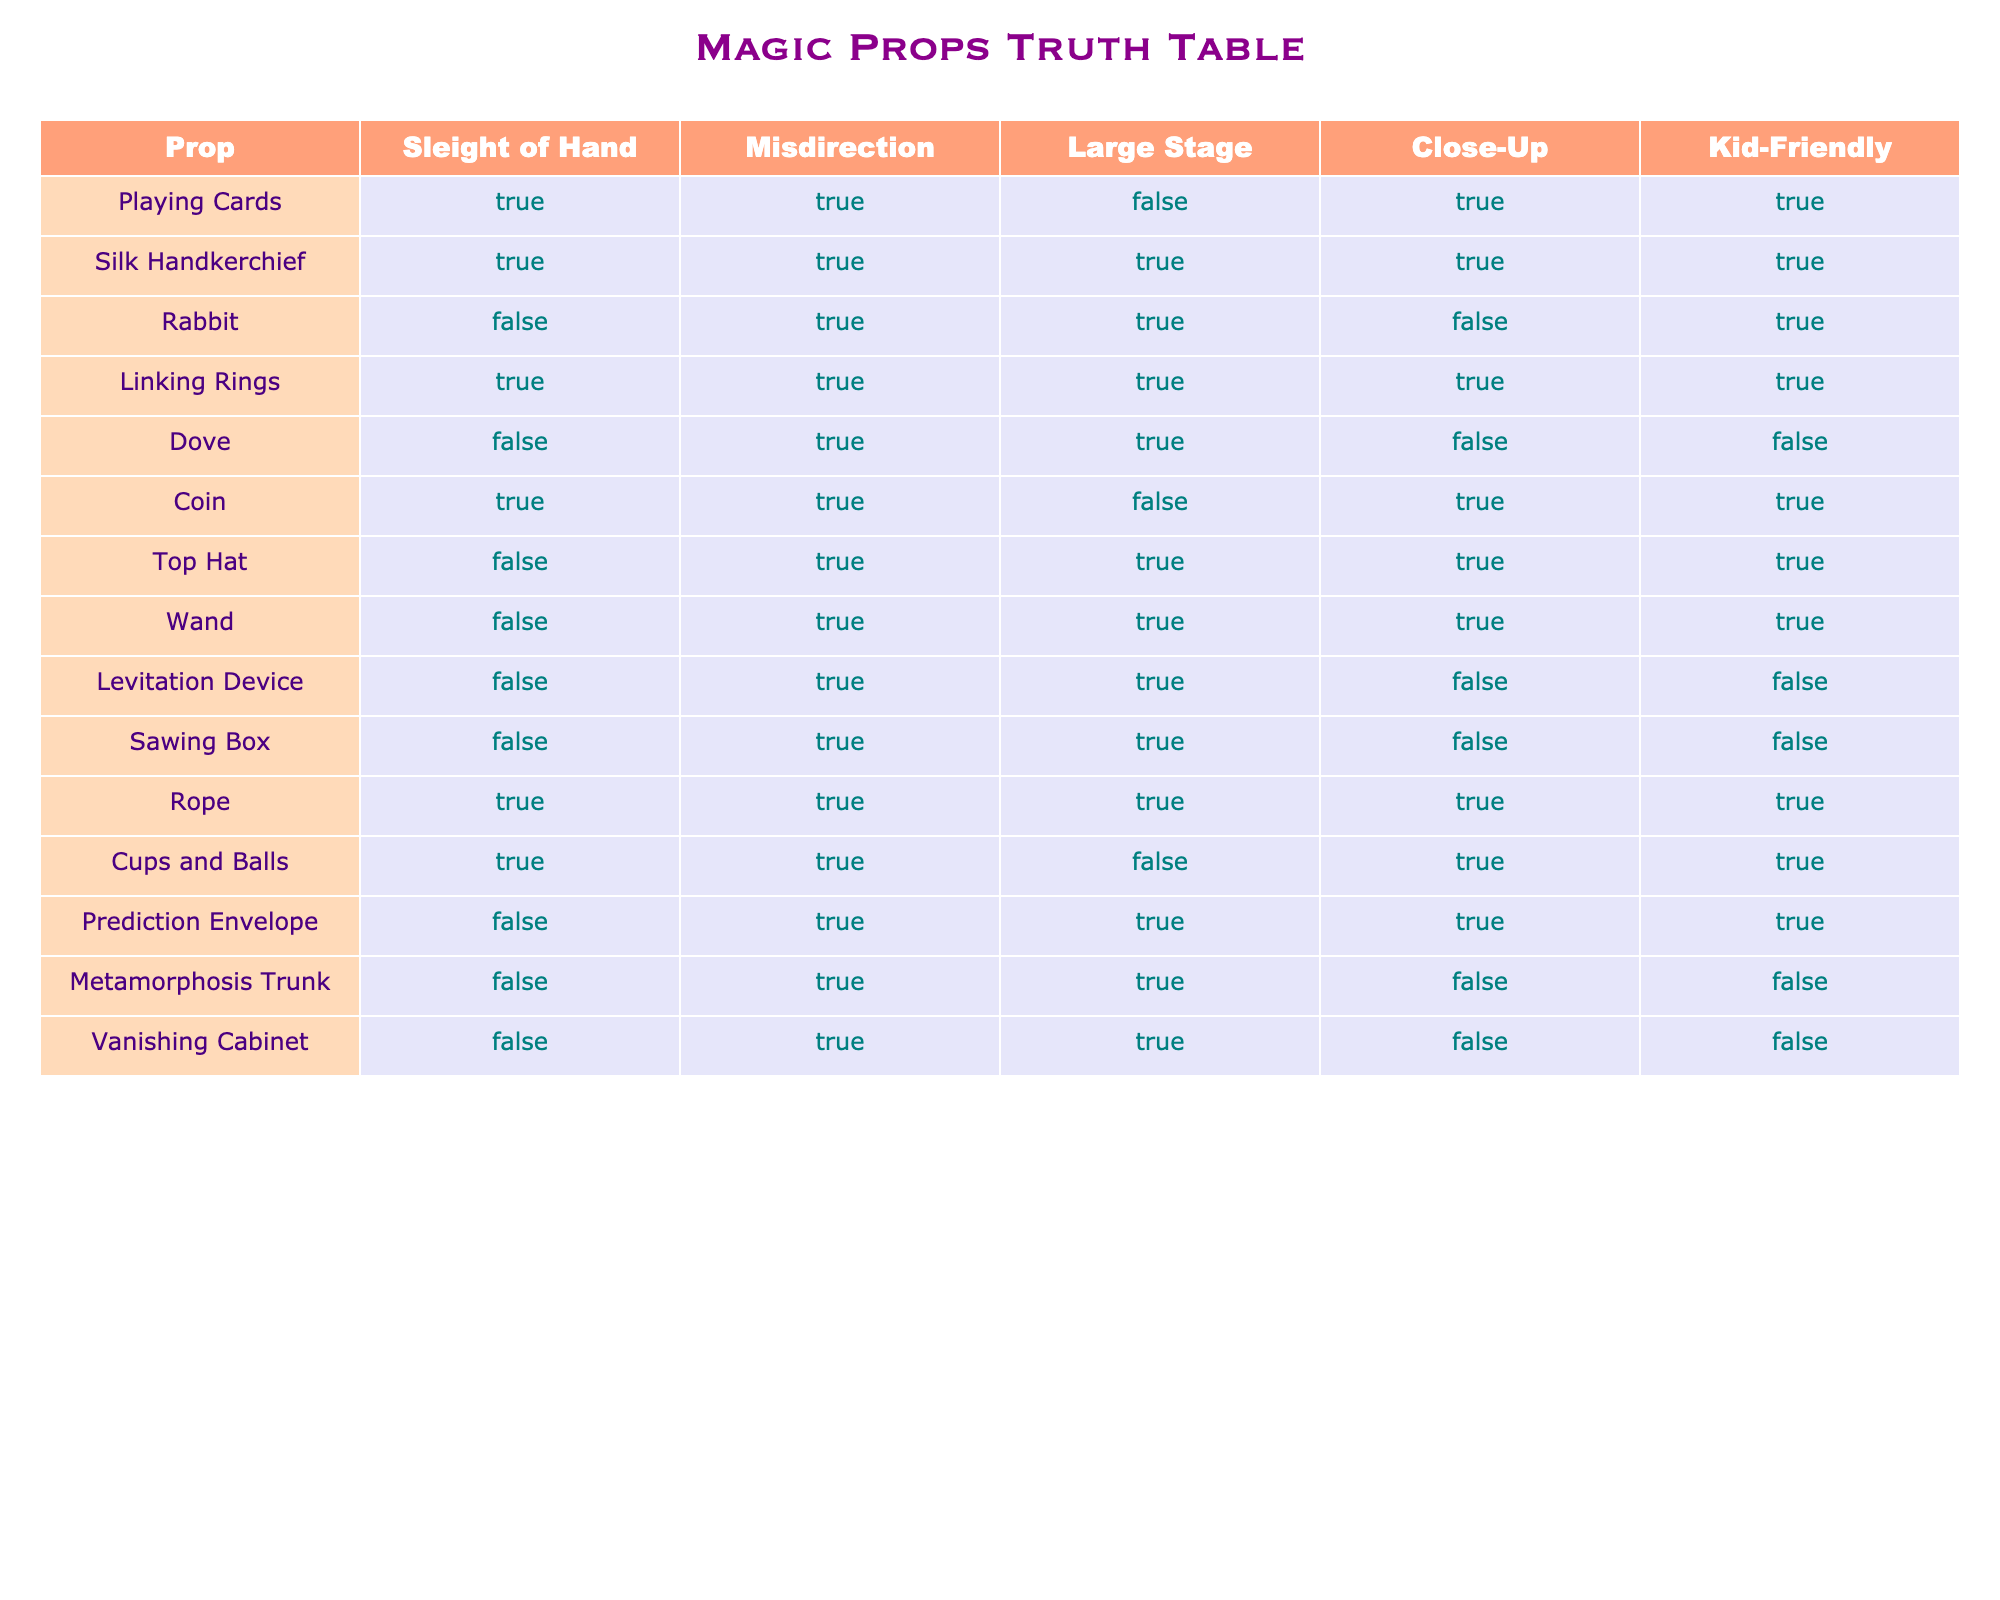What props are suitable for close-up magic? To determine the props suitable for close-up magic, we look for rows where the "Close-Up" column is TRUE. The props that meet this criterion are Playing Cards, Silk Handkerchief, Coin, Rope, Cups and Balls.
Answer: Playing Cards, Silk Handkerchief, Coin, Rope, Cups and Balls Which props can be used on large stages? We examine the rows where the "Large Stage" column is TRUE. The props that can be used on large stages include Silk Handkerchief, Rabbit, Linking Rings, Dove, Top Hat, Wand, Levitation Device, Sawing Box, and Rope.
Answer: Silk Handkerchief, Rabbit, Linking Rings, Dove, Top Hat, Wand, Levitation Device, Sawing Box, Rope Do all props that use sleight of hand also use misdirection? To answer this, we check if every prop with "TRUE" in the "Sleight of Hand" column has "TRUE" in the "Misdirection" column. All matching props (Playing Cards, Silk Handkerchief, Linking Rings, Coin, Cups and Balls, Rope) also have TRUE under "Misdirection."
Answer: Yes How many props can be considered kid-friendly? We count the number of rows where "Kid-Friendly" is TRUE. The props that are kid-friendly are Playing Cards, Silk Handkerchief, Rabbit, Coin, Top Hat, Wand, and Rope. There are 7 such props.
Answer: 7 Is there a prop that is kid-friendly and also suitable for close-up magic but not for large stages? We look for props that have "TRUE" in both "Kid-Friendly" and "Close-Up," while also having "FALSE" in "Large Stage." The only prop that satisfies these conditions is the Coin.
Answer: Yes, Coin What is the total number of props that are capable of using misdirection? We count all rows where "Misdirection" is TRUE. All but one prop (the Rabbit) utilizes misdirection, totaling 11.
Answer: 11 Which props do not require sleight of hand? To identify the props that do not require sleight of hand, we look for "FALSE" in the "Sleight of Hand" column. The props that do not need sleight of hand include Rabbit, Dove, Top Hat, Wand, Levitation Device, Sawing Box, Metamorphosis Trunk, and Vanishing Cabinet.
Answer: Rabbit, Dove, Top Hat, Wand, Levitation Device, Sawing Box, Metamorphosis Trunk, Vanishing Cabinet How many props are suitable for both close-up magic and large stages? We check the table for props that have TRUE in both the "Close-Up" and "Large Stage" columns. The only props that fit are Rope and Top Hat, making a total of 2.
Answer: 2 What percent of the analyzed props are traditionally kid-friendly? We find that 7 out of the 12 total props are kid-friendly. To determine the percentage, we calculate (7 / 12) * 100 = 58.33%.
Answer: 58.33% 